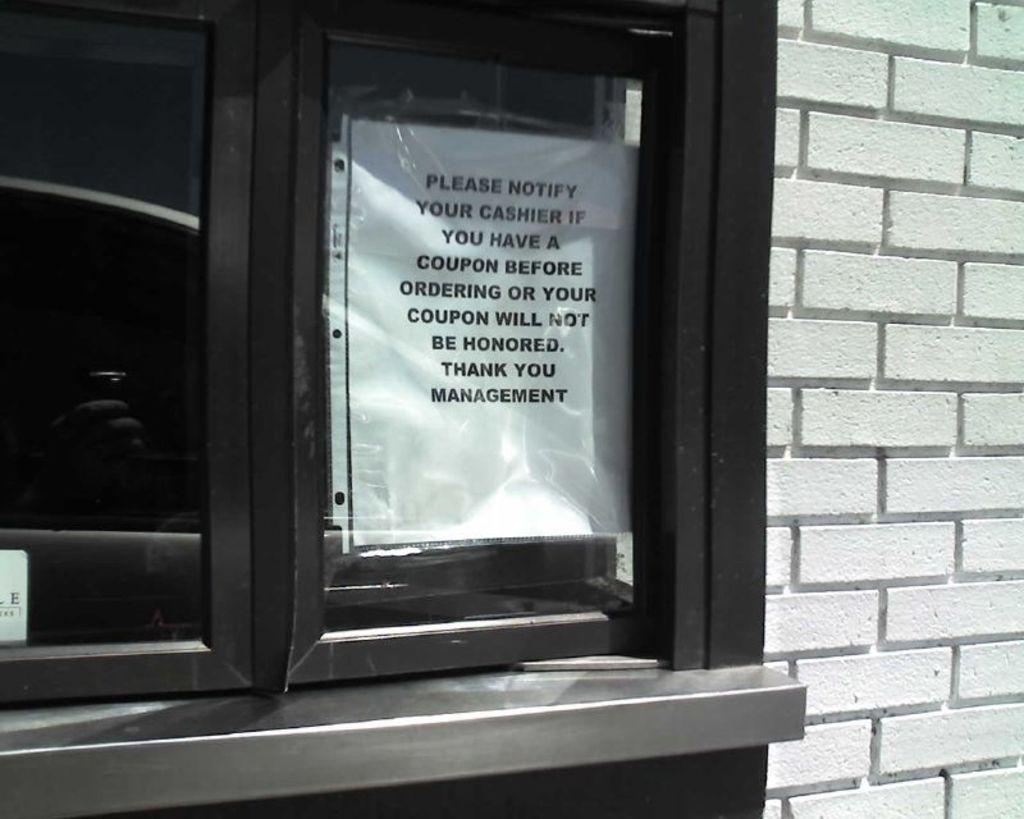What is located on the left side of the image? There is a window on the left side of the image. What is attached to the window? A white color paper is attached to the window. What can be seen on the right side of the image? There is a wall on the right side of the image. What is the income of the person who placed the white paper on the window? There is no information about the person's income in the image, as it only shows a window with a white paper attached to it and a wall on the right side. Can you see any waves in the image? There are no waves present in the image; it features a window with a white paper attached to it and a wall on the right side. 